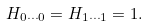Convert formula to latex. <formula><loc_0><loc_0><loc_500><loc_500>H _ { 0 \cdots 0 } = H _ { 1 \cdots 1 } = 1 .</formula> 